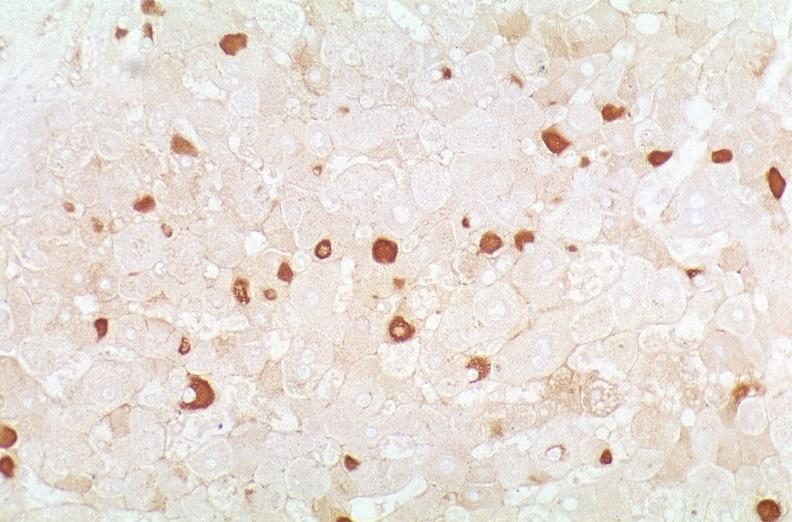what is present?
Answer the question using a single word or phrase. Liver 